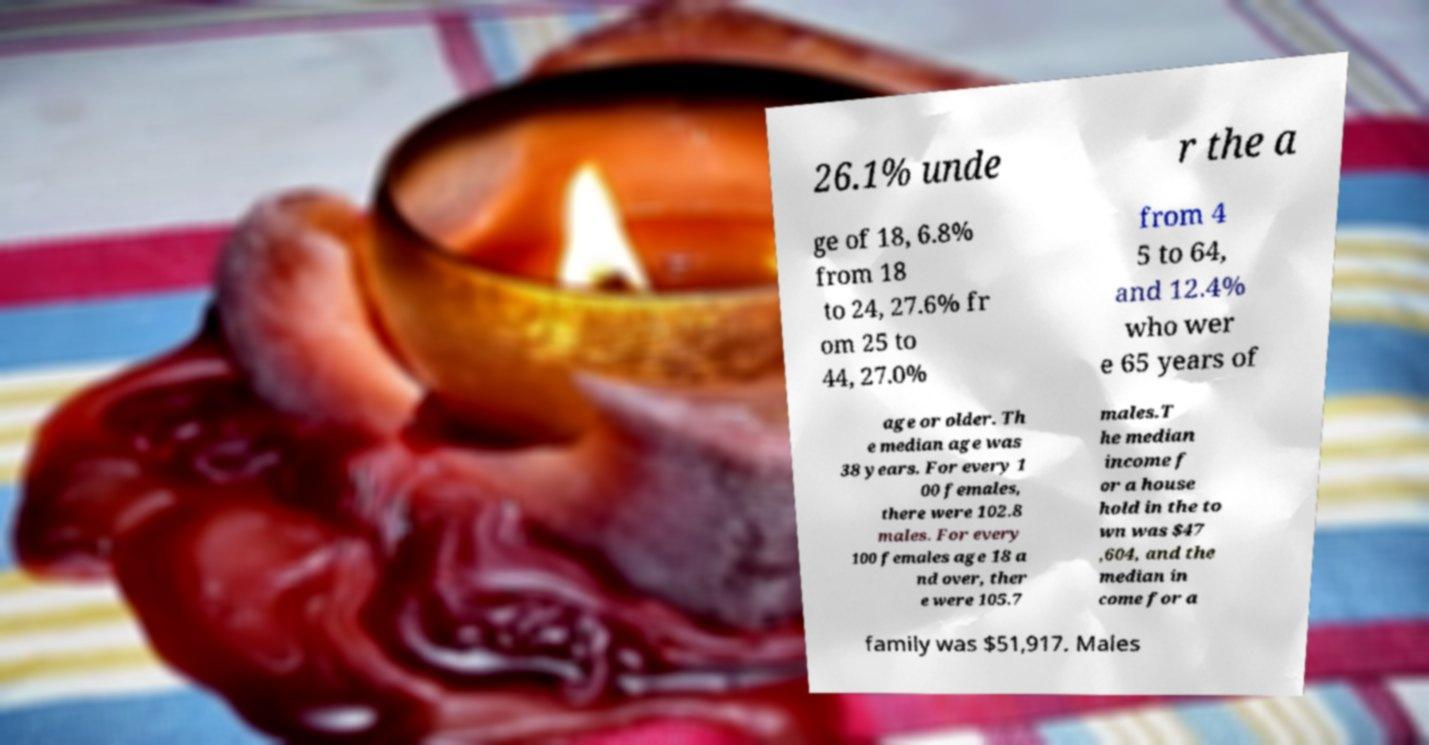Could you assist in decoding the text presented in this image and type it out clearly? 26.1% unde r the a ge of 18, 6.8% from 18 to 24, 27.6% fr om 25 to 44, 27.0% from 4 5 to 64, and 12.4% who wer e 65 years of age or older. Th e median age was 38 years. For every 1 00 females, there were 102.8 males. For every 100 females age 18 a nd over, ther e were 105.7 males.T he median income f or a house hold in the to wn was $47 ,604, and the median in come for a family was $51,917. Males 